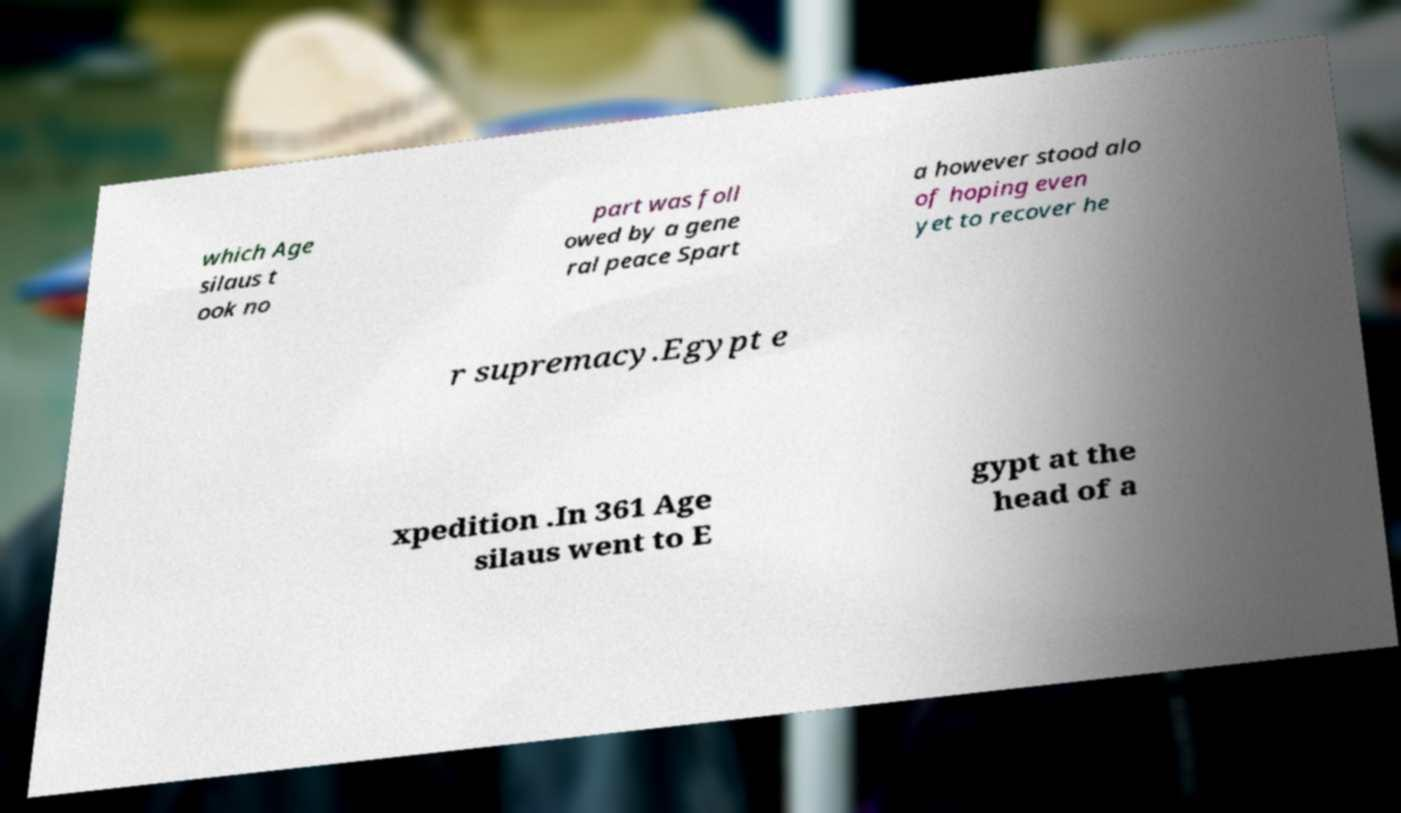There's text embedded in this image that I need extracted. Can you transcribe it verbatim? which Age silaus t ook no part was foll owed by a gene ral peace Spart a however stood alo of hoping even yet to recover he r supremacy.Egypt e xpedition .In 361 Age silaus went to E gypt at the head of a 